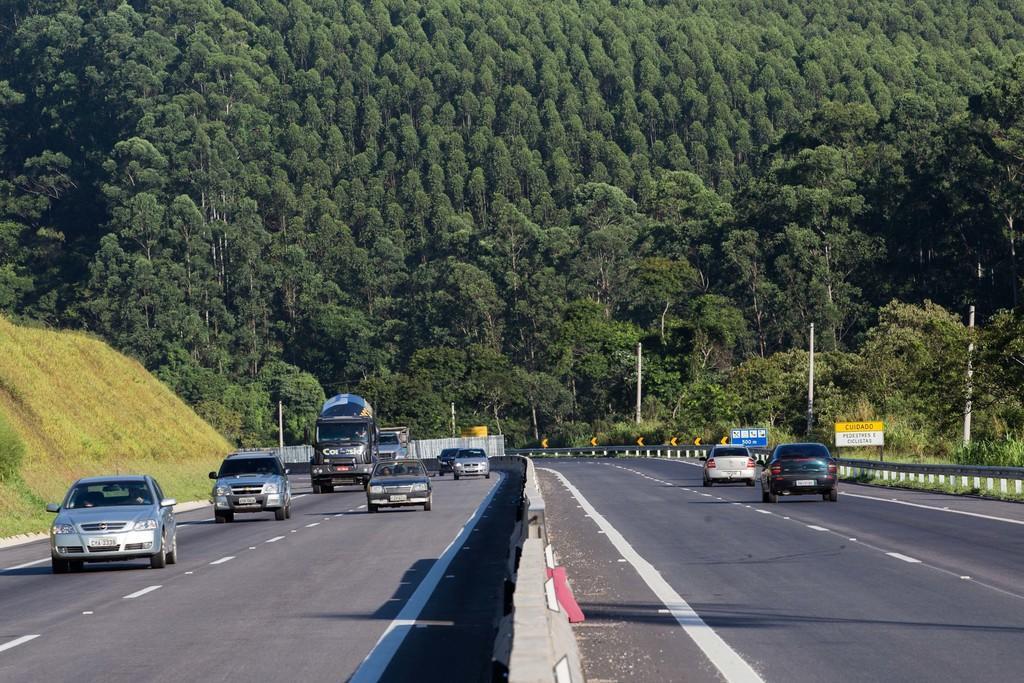Could you give a brief overview of what you see in this image? In this picture there are vehicles moving on the road and in the background there are trees. On the left side there is grass. On the right side there are poles and there are boards with some text written on it and there are plants and trees. 